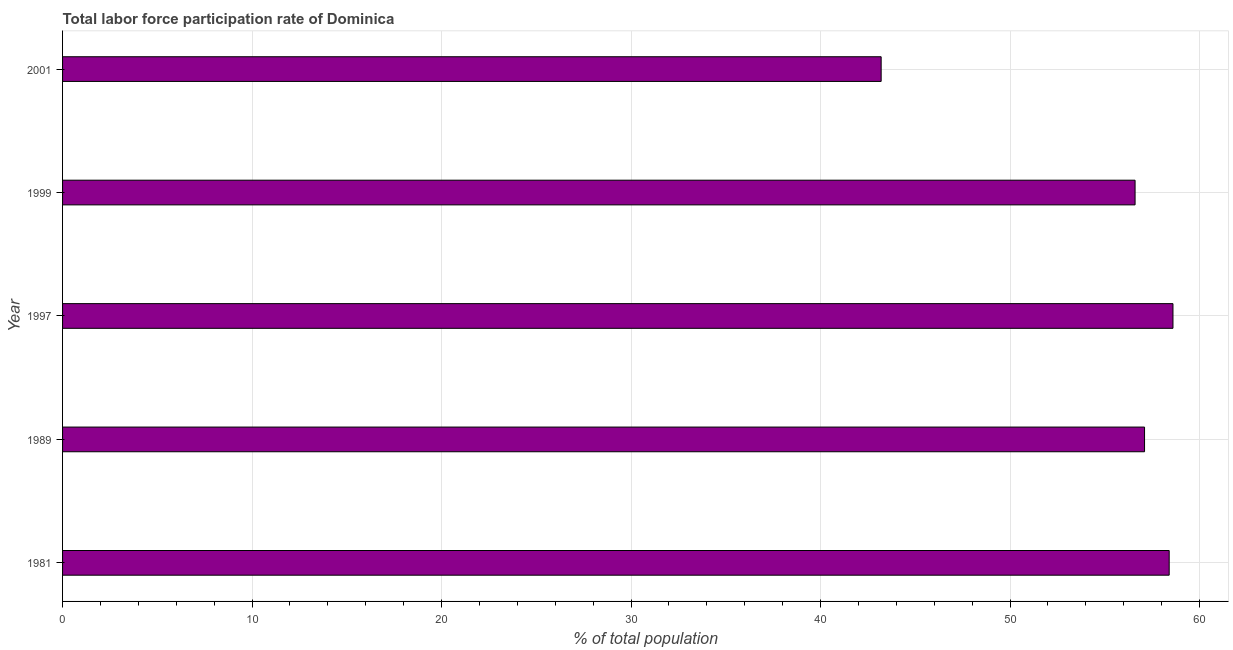Does the graph contain any zero values?
Give a very brief answer. No. Does the graph contain grids?
Your answer should be compact. Yes. What is the title of the graph?
Ensure brevity in your answer.  Total labor force participation rate of Dominica. What is the label or title of the X-axis?
Provide a short and direct response. % of total population. What is the total labor force participation rate in 2001?
Keep it short and to the point. 43.2. Across all years, what is the maximum total labor force participation rate?
Give a very brief answer. 58.6. Across all years, what is the minimum total labor force participation rate?
Your response must be concise. 43.2. In which year was the total labor force participation rate minimum?
Provide a succinct answer. 2001. What is the sum of the total labor force participation rate?
Your answer should be compact. 273.9. What is the difference between the total labor force participation rate in 1981 and 2001?
Ensure brevity in your answer.  15.2. What is the average total labor force participation rate per year?
Offer a very short reply. 54.78. What is the median total labor force participation rate?
Your answer should be compact. 57.1. Do a majority of the years between 2001 and 1989 (inclusive) have total labor force participation rate greater than 56 %?
Provide a short and direct response. Yes. What is the ratio of the total labor force participation rate in 1997 to that in 2001?
Your answer should be compact. 1.36. Is the total labor force participation rate in 1997 less than that in 1999?
Your answer should be very brief. No. Is the difference between the total labor force participation rate in 1999 and 2001 greater than the difference between any two years?
Keep it short and to the point. No. Is the sum of the total labor force participation rate in 1981 and 2001 greater than the maximum total labor force participation rate across all years?
Your answer should be very brief. Yes. What is the difference between the highest and the lowest total labor force participation rate?
Keep it short and to the point. 15.4. How many bars are there?
Give a very brief answer. 5. Are all the bars in the graph horizontal?
Keep it short and to the point. Yes. What is the difference between two consecutive major ticks on the X-axis?
Ensure brevity in your answer.  10. Are the values on the major ticks of X-axis written in scientific E-notation?
Make the answer very short. No. What is the % of total population of 1981?
Make the answer very short. 58.4. What is the % of total population of 1989?
Your response must be concise. 57.1. What is the % of total population in 1997?
Provide a short and direct response. 58.6. What is the % of total population in 1999?
Offer a very short reply. 56.6. What is the % of total population in 2001?
Keep it short and to the point. 43.2. What is the difference between the % of total population in 1989 and 1997?
Provide a succinct answer. -1.5. What is the difference between the % of total population in 1989 and 1999?
Your answer should be compact. 0.5. What is the difference between the % of total population in 1989 and 2001?
Provide a short and direct response. 13.9. What is the ratio of the % of total population in 1981 to that in 1989?
Your answer should be very brief. 1.02. What is the ratio of the % of total population in 1981 to that in 1999?
Ensure brevity in your answer.  1.03. What is the ratio of the % of total population in 1981 to that in 2001?
Ensure brevity in your answer.  1.35. What is the ratio of the % of total population in 1989 to that in 1999?
Your answer should be very brief. 1.01. What is the ratio of the % of total population in 1989 to that in 2001?
Provide a short and direct response. 1.32. What is the ratio of the % of total population in 1997 to that in 1999?
Provide a succinct answer. 1.03. What is the ratio of the % of total population in 1997 to that in 2001?
Your answer should be very brief. 1.36. What is the ratio of the % of total population in 1999 to that in 2001?
Offer a terse response. 1.31. 